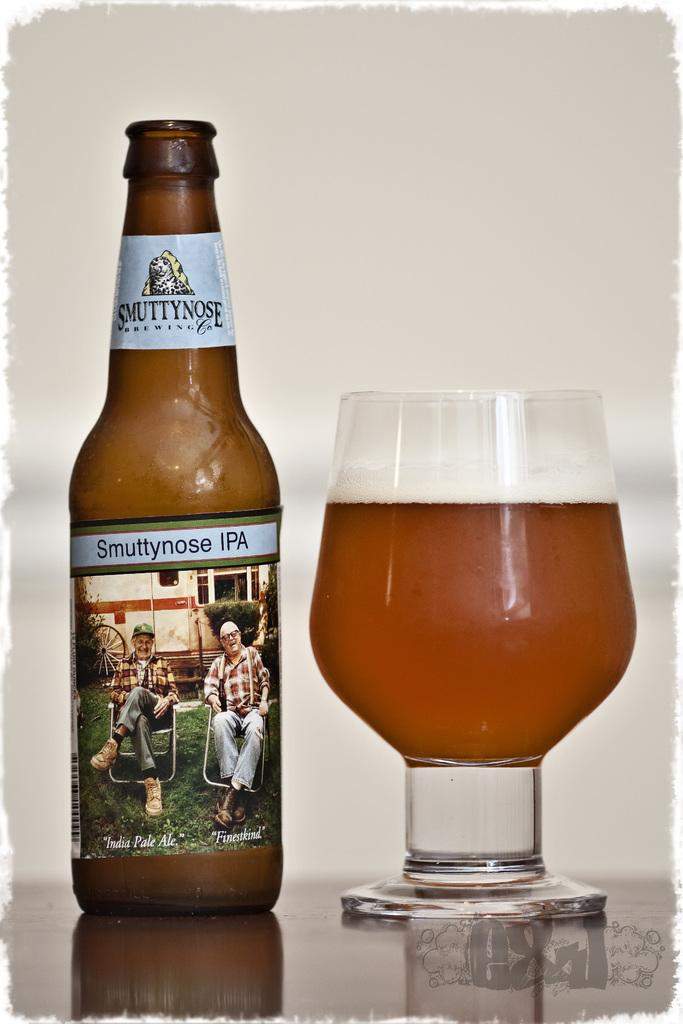<image>
Describe the image concisely. A bottle of Smuttynose IPA sitting on a table to the left of a glass. 